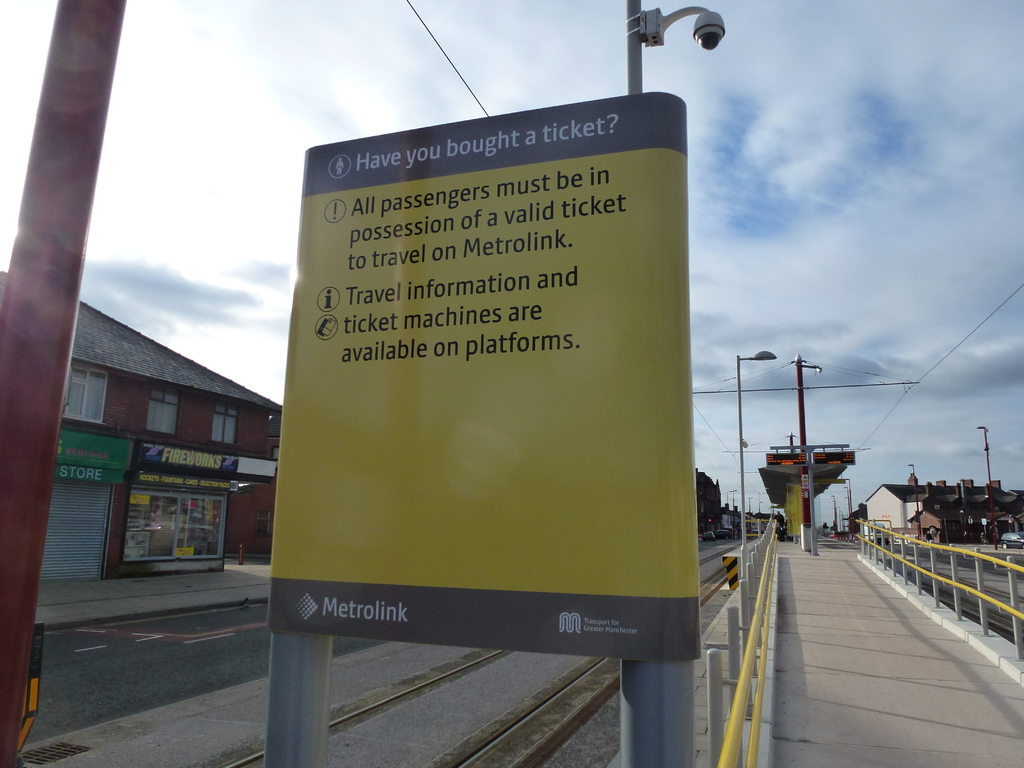Can you describe what kind of area surrounds the Metrolink station? The Metrolink station is situated in a commercial area, as indicated by the storefronts visible behind the sign. These stores include a variety of small businesses, likely catering to the daily needs of commuters and local residents. The presence of overhead tram lines and visible tram station components suggest a well-integrated public transport system within this urban setting. 